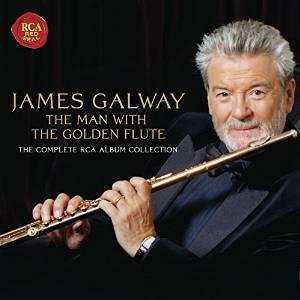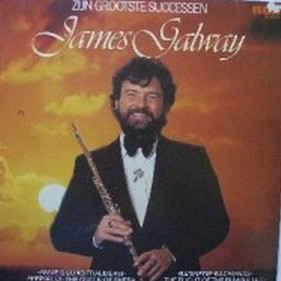The first image is the image on the left, the second image is the image on the right. Evaluate the accuracy of this statement regarding the images: "An image shows a man with a gray beard in a dark suit, holding a flute up to his ear with the hand on the left.". Is it true? Answer yes or no. No. 